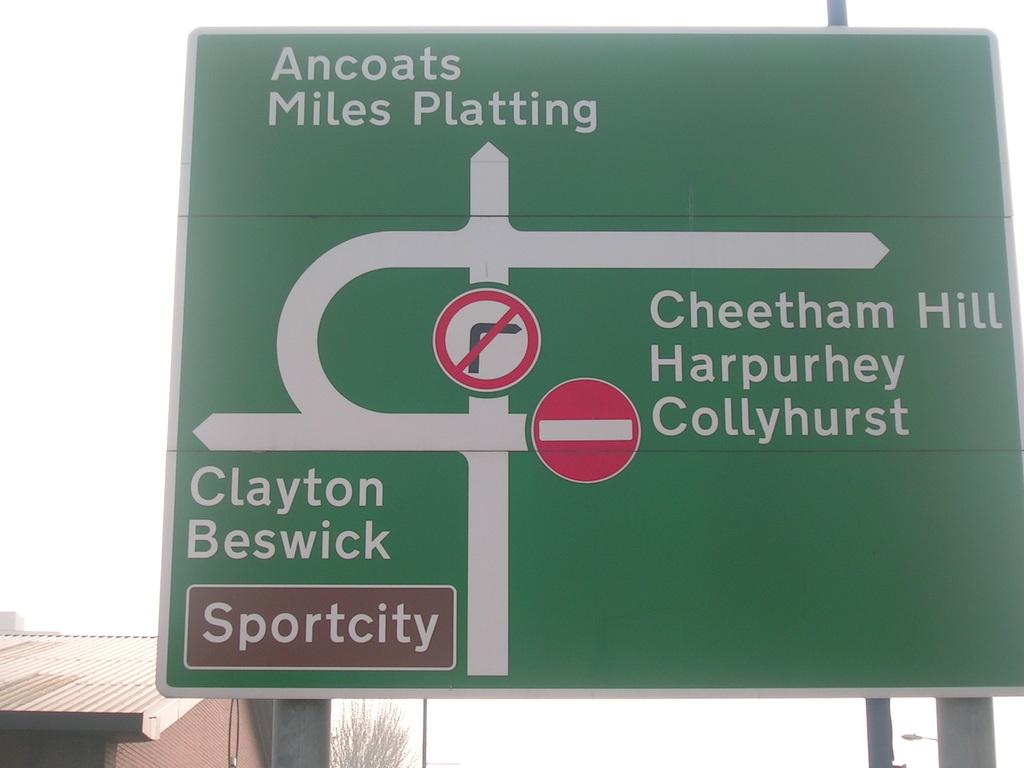<image>
Write a terse but informative summary of the picture. A white and green street sign says sport city in the bottom left hand side. 